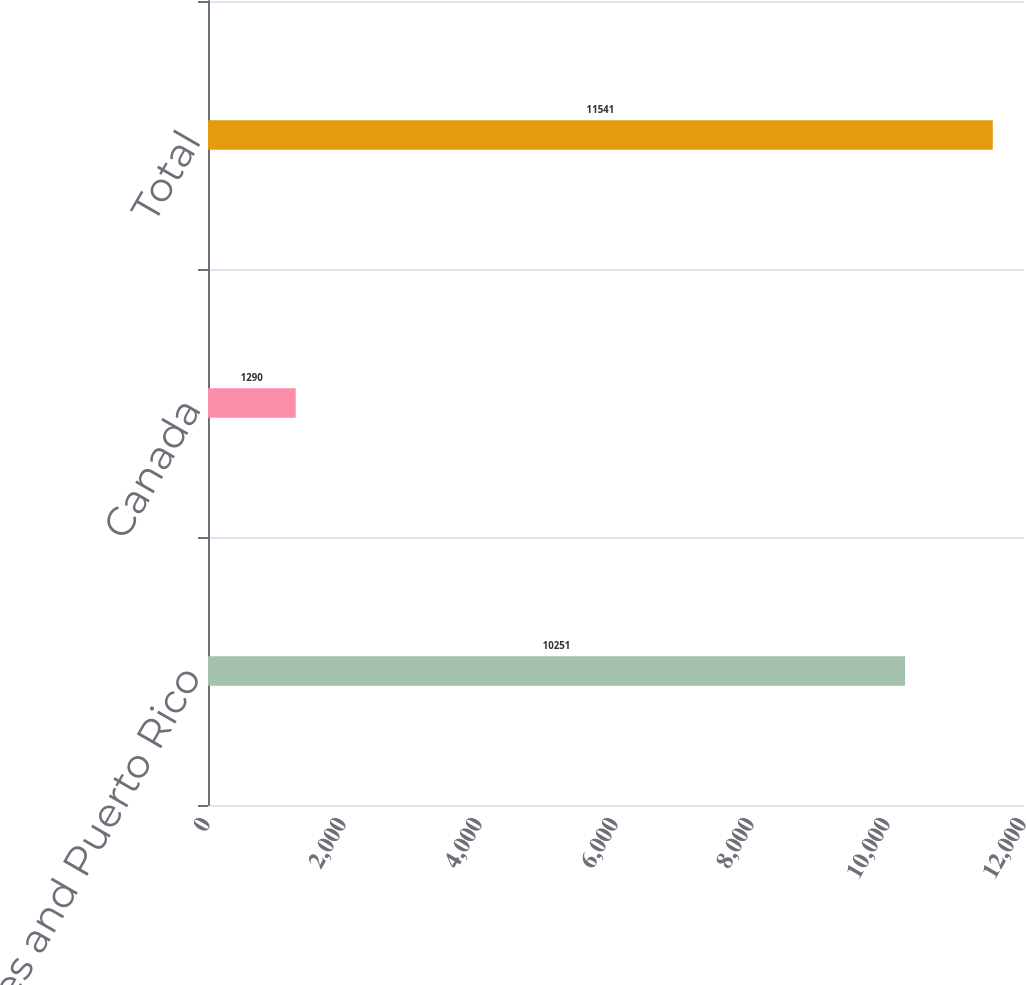Convert chart. <chart><loc_0><loc_0><loc_500><loc_500><bar_chart><fcel>United States and Puerto Rico<fcel>Canada<fcel>Total<nl><fcel>10251<fcel>1290<fcel>11541<nl></chart> 